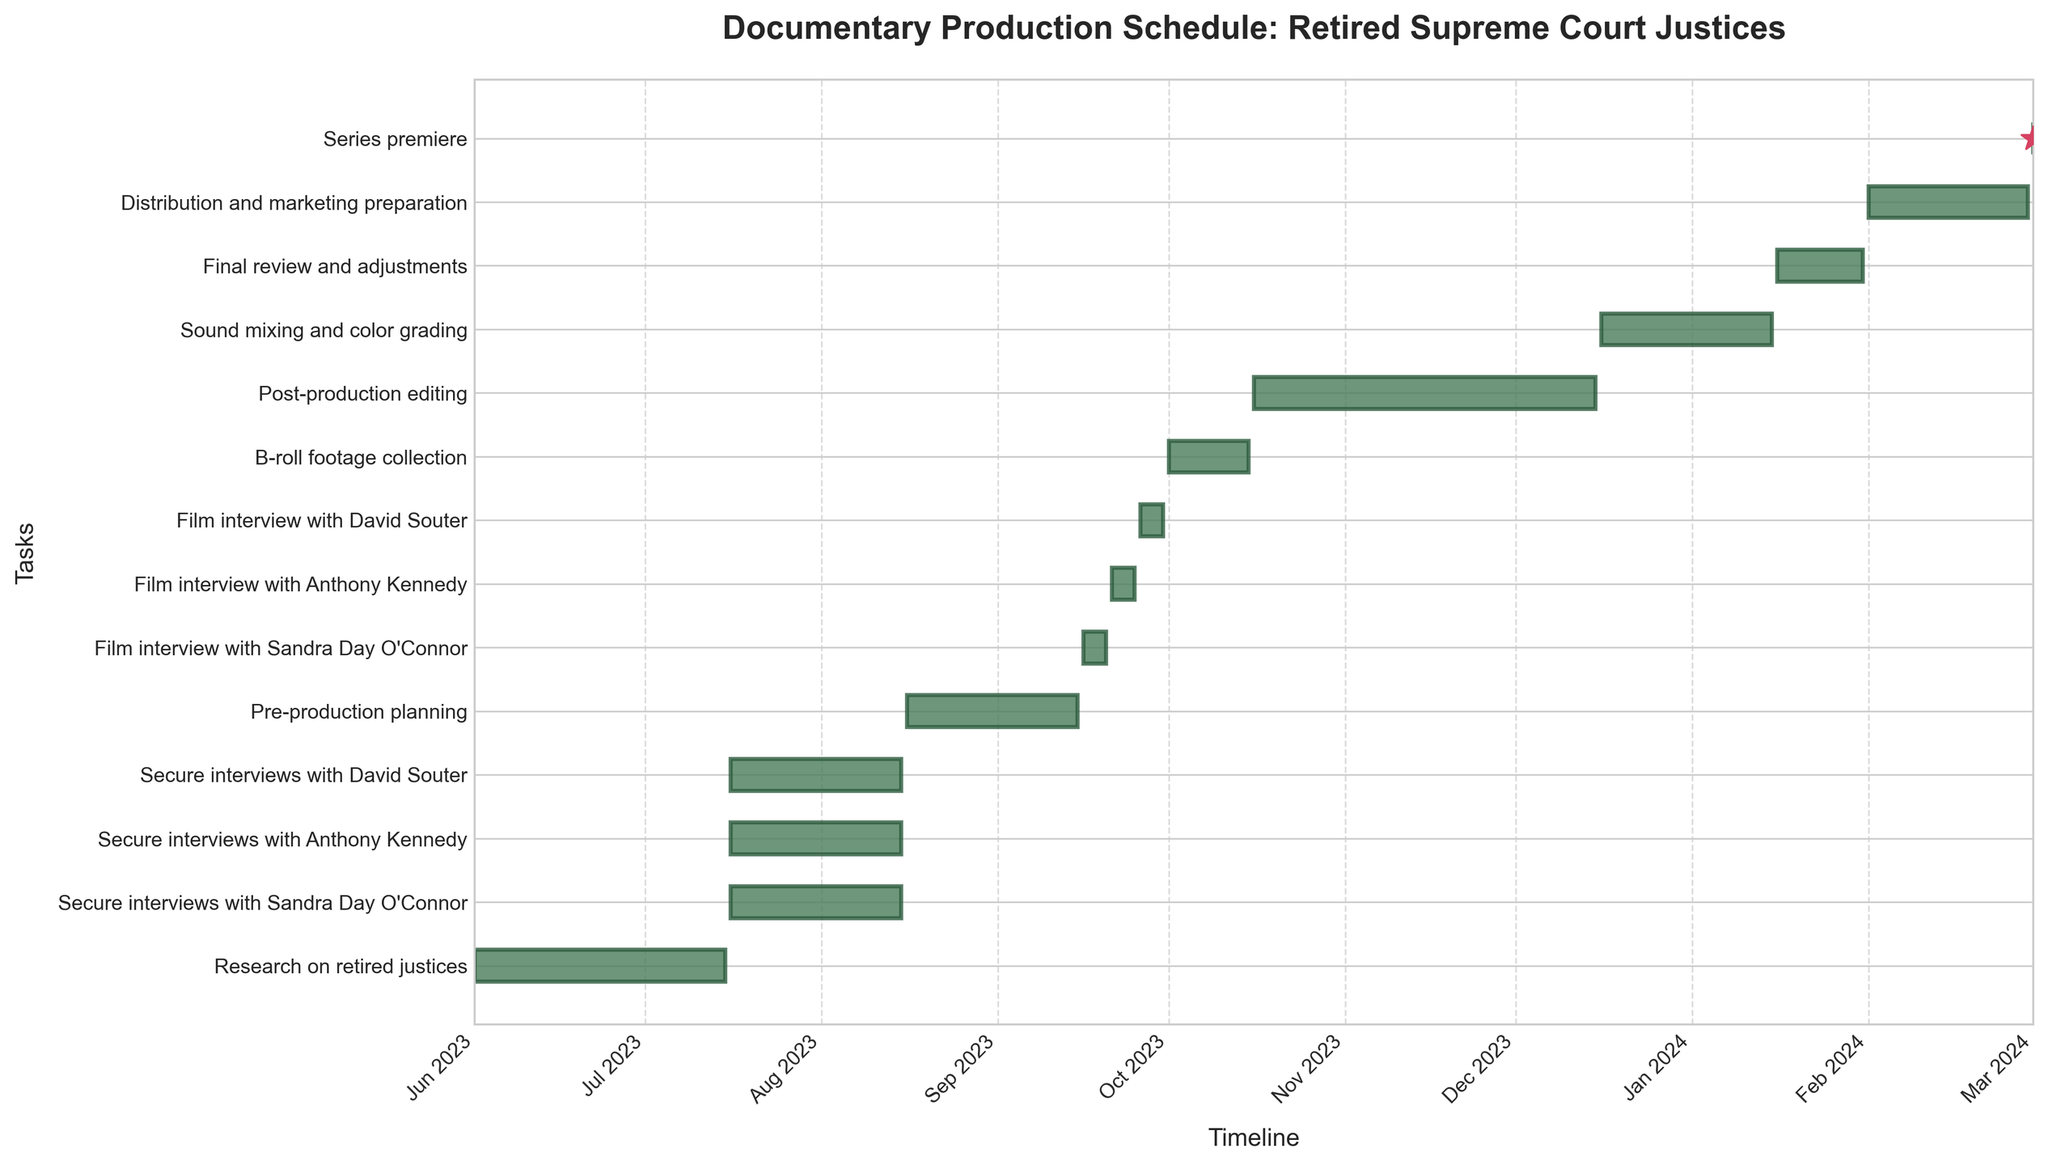What is the title of the Gantt Chart? The title is located at the top of the chart and reads "Documentary Production Schedule: Retired Supreme Court Justices".
Answer: Documentary Production Schedule: Retired Supreme Court Justices Which task will start first in the documentary production schedule? The first task is the one that starts earliest in the timeline, which is "Research on retired justices" starting on June 1, 2023.
Answer: Research on retired justices How many days are allocated for the task "Post-production editing"? The duration of "Post-production editing" can be calculated by subtracting its start date (October 16, 2023) from its end date (December 15, 2023), resulting in 61 days.
Answer: 61 days What is the timeline for filming the interviews with the retired justices? Filming for Sandra Day O'Connor is from September 16-20, Anthony Kennedy from September 21-25, and David Souter from September 26-30, all in 2023.
Answer: September 16-30, 2023 Which task follows the filming of the last interview? The task immediately after the final interview (David Souter's on September 30) is "B-roll footage collection" starting on October 1, 2023.
Answer: B-roll footage collection When is the series premiere scheduled to occur? The series premiere date is marked by a milestone star on the timeline and is scheduled for March 1, 2024.
Answer: March 1, 2024 Compare the duration of "Pre-production planning" with "Distribution and marketing preparation". Which one takes longer? Calculate the duration of each: "Pre-production planning" (August 16 - September 15, 2023) takes 31 days, while "Distribution and marketing preparation" (February 1 - 29, 2024) takes 29 days, so "Pre-production planning" is longer.
Answer: Pre-production planning What is the total duration from the start of research to the series premiere? The total duration is from June 1, 2023 (start of research) to March 1, 2024 (premiere), which is 275 days.
Answer: 275 days In which month does the task "Sound mixing and color grading" end? The end date for "Sound mixing and color grading" is January 15, 2024, so it ends in January.
Answer: January 2024 Which task takes place immediately before "Post-production editing"? The task right before "Post-production editing," which starts on October 16, 2023, is "B-roll footage collection," which ends on October 15, 2023.
Answer: B-roll footage collection 